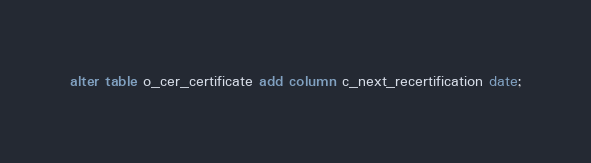<code> <loc_0><loc_0><loc_500><loc_500><_SQL_>alter table o_cer_certificate add column c_next_recertification date;</code> 